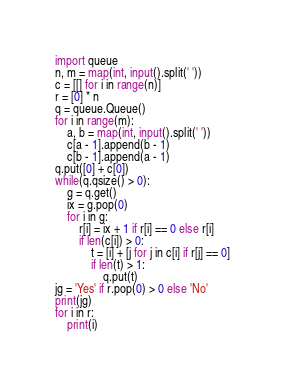Convert code to text. <code><loc_0><loc_0><loc_500><loc_500><_Python_>import queue
n, m = map(int, input().split(' '))
c = [[] for i in range(n)]
r = [0] * n
q = queue.Queue()
for i in range(m):
    a, b = map(int, input().split(' '))
    c[a - 1].append(b - 1)
    c[b - 1].append(a - 1)
q.put([0] + c[0])
while(q.qsize() > 0):
    g = q.get()
    ix = g.pop(0)
    for i in g:
        r[i] = ix + 1 if r[i] == 0 else r[i]
        if len(c[i]) > 0:
            t = [i] + [j for j in c[i] if r[j] == 0]
            if len(t) > 1:
                q.put(t)
jg = 'Yes' if r.pop(0) > 0 else 'No'
print(jg)
for i in r:
    print(i)</code> 